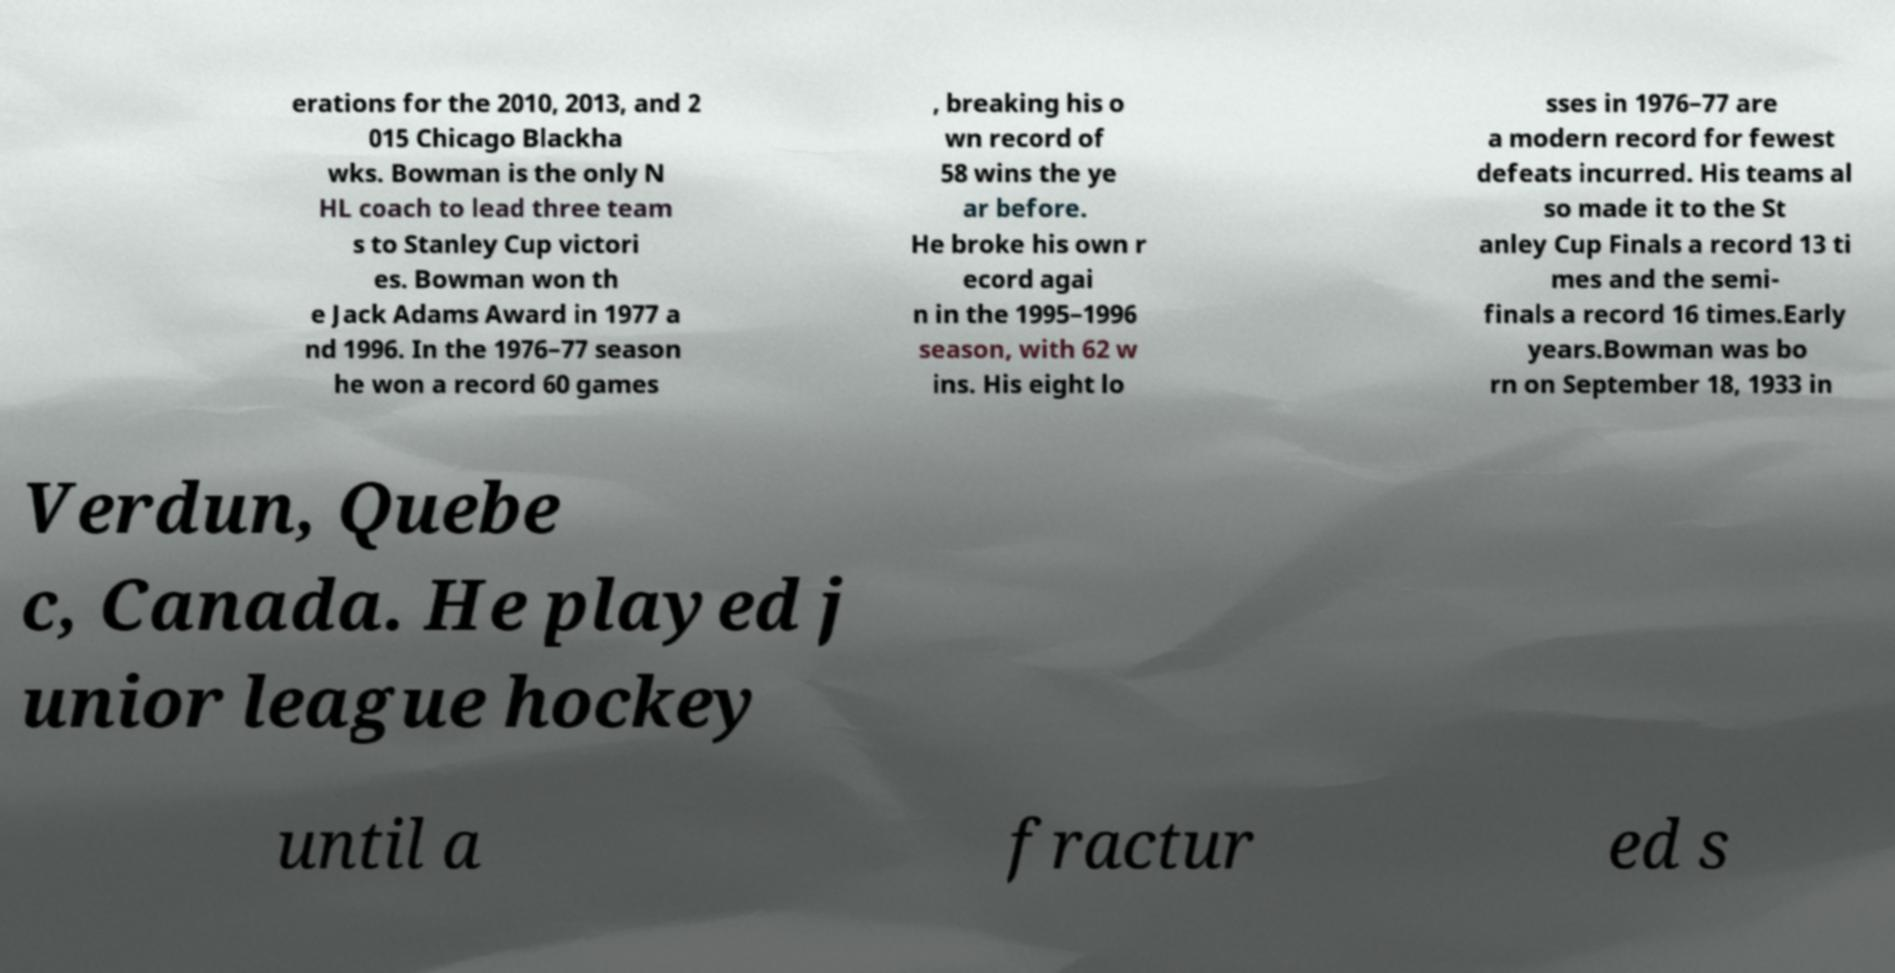Please read and relay the text visible in this image. What does it say? erations for the 2010, 2013, and 2 015 Chicago Blackha wks. Bowman is the only N HL coach to lead three team s to Stanley Cup victori es. Bowman won th e Jack Adams Award in 1977 a nd 1996. In the 1976–77 season he won a record 60 games , breaking his o wn record of 58 wins the ye ar before. He broke his own r ecord agai n in the 1995–1996 season, with 62 w ins. His eight lo sses in 1976–77 are a modern record for fewest defeats incurred. His teams al so made it to the St anley Cup Finals a record 13 ti mes and the semi- finals a record 16 times.Early years.Bowman was bo rn on September 18, 1933 in Verdun, Quebe c, Canada. He played j unior league hockey until a fractur ed s 